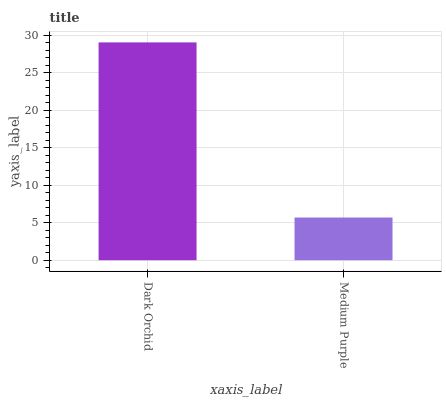Is Medium Purple the minimum?
Answer yes or no. Yes. Is Dark Orchid the maximum?
Answer yes or no. Yes. Is Medium Purple the maximum?
Answer yes or no. No. Is Dark Orchid greater than Medium Purple?
Answer yes or no. Yes. Is Medium Purple less than Dark Orchid?
Answer yes or no. Yes. Is Medium Purple greater than Dark Orchid?
Answer yes or no. No. Is Dark Orchid less than Medium Purple?
Answer yes or no. No. Is Dark Orchid the high median?
Answer yes or no. Yes. Is Medium Purple the low median?
Answer yes or no. Yes. Is Medium Purple the high median?
Answer yes or no. No. Is Dark Orchid the low median?
Answer yes or no. No. 